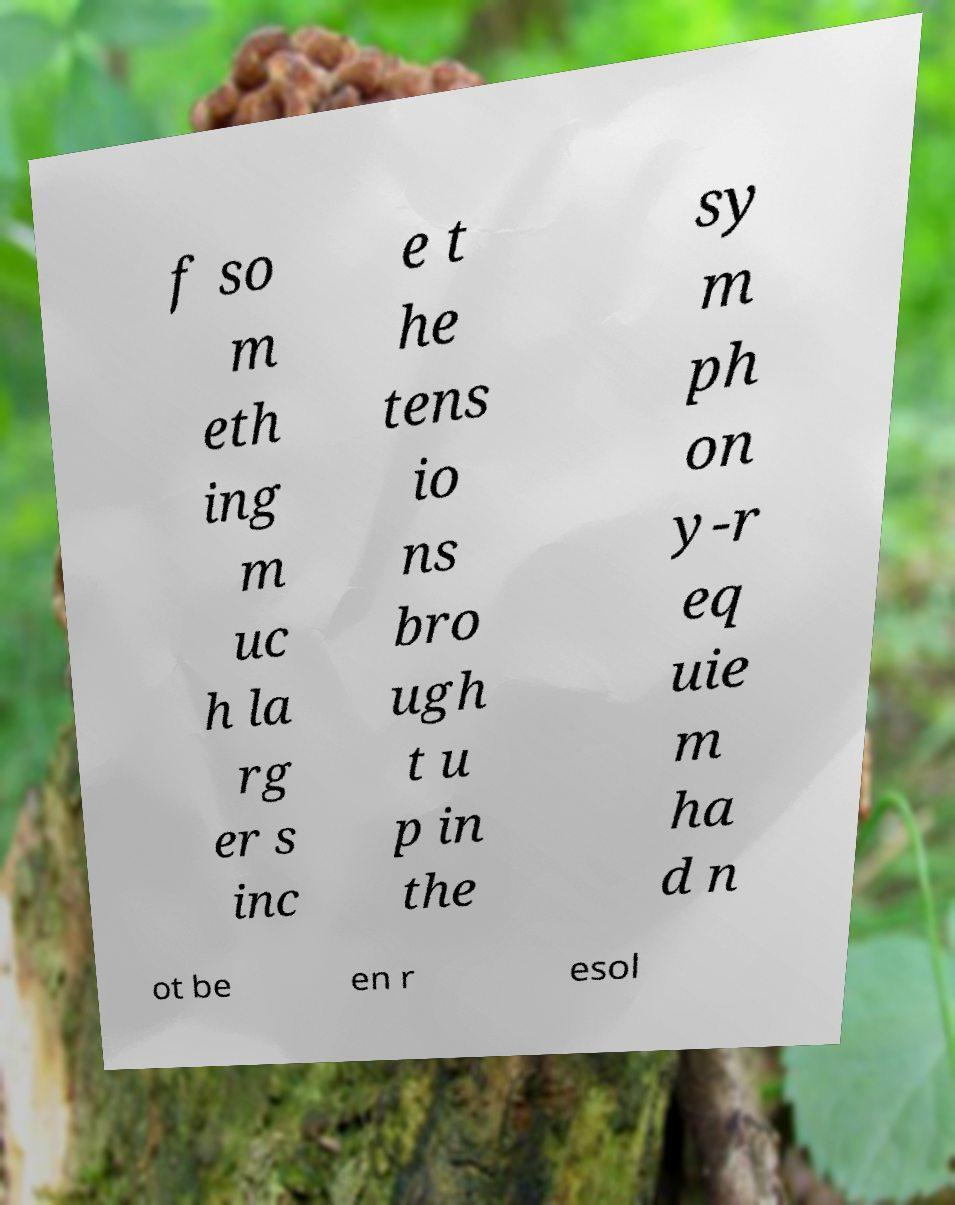For documentation purposes, I need the text within this image transcribed. Could you provide that? f so m eth ing m uc h la rg er s inc e t he tens io ns bro ugh t u p in the sy m ph on y-r eq uie m ha d n ot be en r esol 